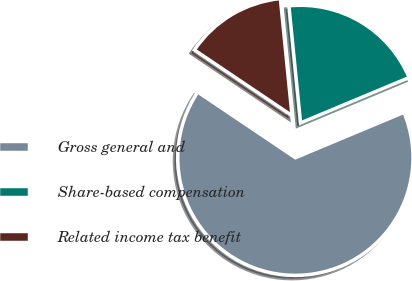<chart> <loc_0><loc_0><loc_500><loc_500><pie_chart><fcel>Gross general and<fcel>Share-based compensation<fcel>Related income tax benefit<nl><fcel>65.73%<fcel>20.28%<fcel>13.99%<nl></chart> 